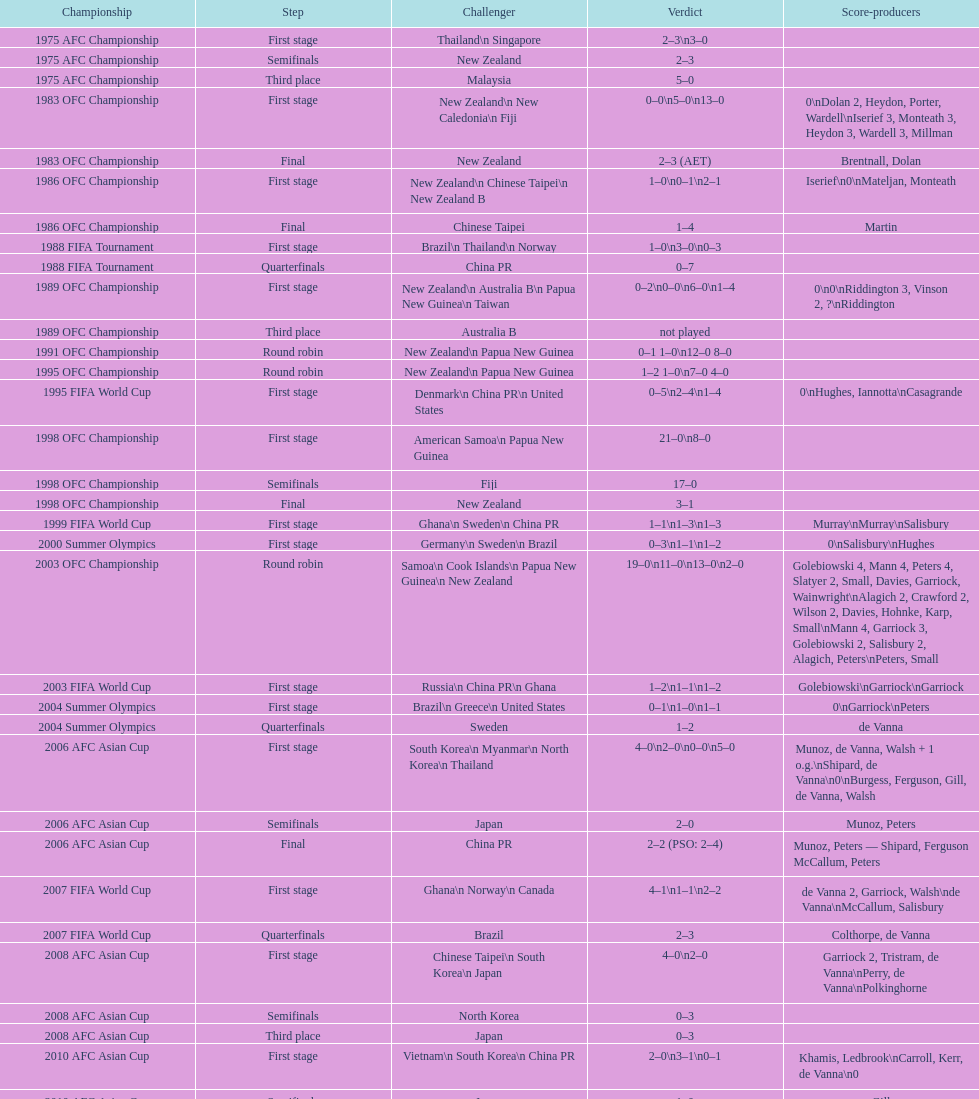What is the difference in the number of goals scored in the 1999 fifa world cup and the 2000 summer olympics? 2. 